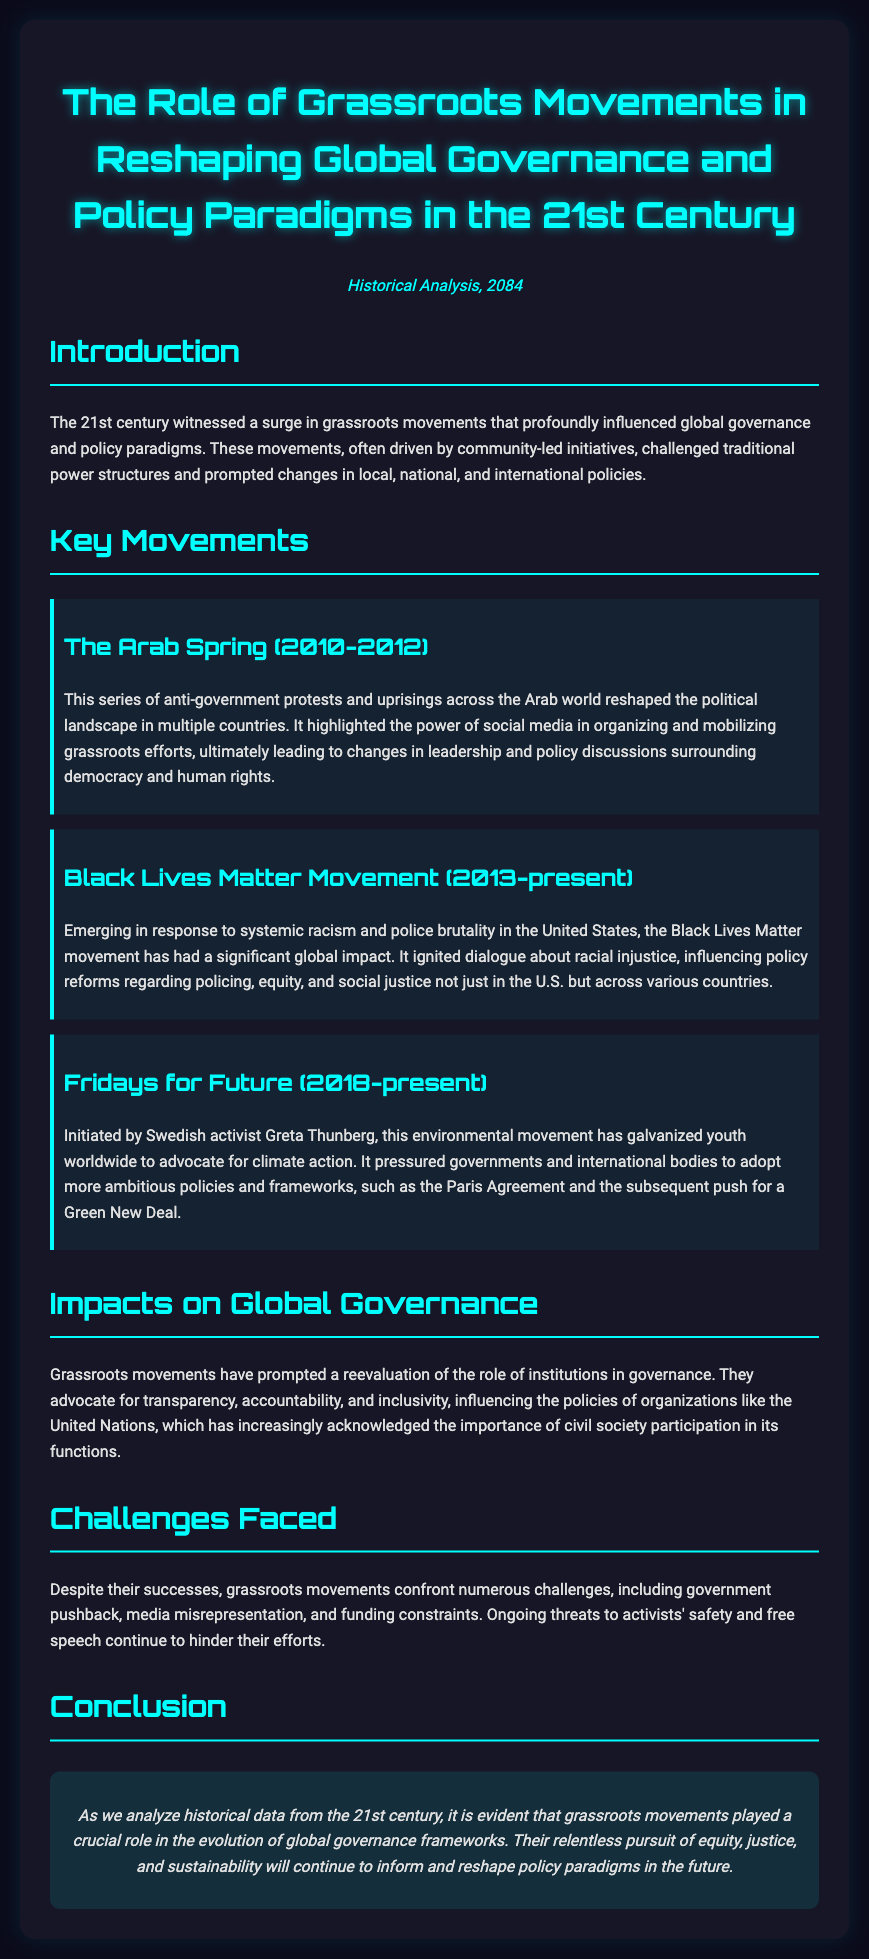What was the title of the document? The title is provided in the heading of the document, which is: "The Role of Grassroots Movements in Reshaping Global Governance and Policy Paradigms in the 21st Century."
Answer: The Role of Grassroots Movements in Reshaping Global Governance and Policy Paradigms in the 21st Century When did the Arab Spring take place? The document specifies the time frame of the Arab Spring as occurring between the years 2010 and 2012.
Answer: 2010-2012 Who initiated the Fridays for Future movement? The document names Greta Thunberg as the Swedish activist who initiated the Fridays for Future movement.
Answer: Greta Thunberg What issue does the Black Lives Matter movement primarily address? The document clearly states that the Black Lives Matter movement emerged in response to systemic racism and police brutality.
Answer: Systemic racism and police brutality What has been a significant influence of grassroots movements on global governance? The document mentions that grassroots movements have influenced the policies of organizations like the United Nations to acknowledge civil society participation.
Answer: Acknowledgment of civil society participation What are some challenges faced by grassroots movements? The document outlines several challenges, including government pushback, media misrepresentation, and funding constraints.
Answer: Government pushback, media misrepresentation, and funding constraints What is the conclusion about the role of grassroots movements? The conclusion states that grassroots movements played a crucial role in the evolution of global governance frameworks, focusing on equity and sustainability.
Answer: Played a crucial role in the evolution of global governance frameworks How has the Black Lives Matter movement impacted policy? It has ignited dialogue about racial injustice and influenced policy reforms regarding policing, equity, and social justice.
Answer: Influenced policy reforms regarding policing, equity, and social justice 